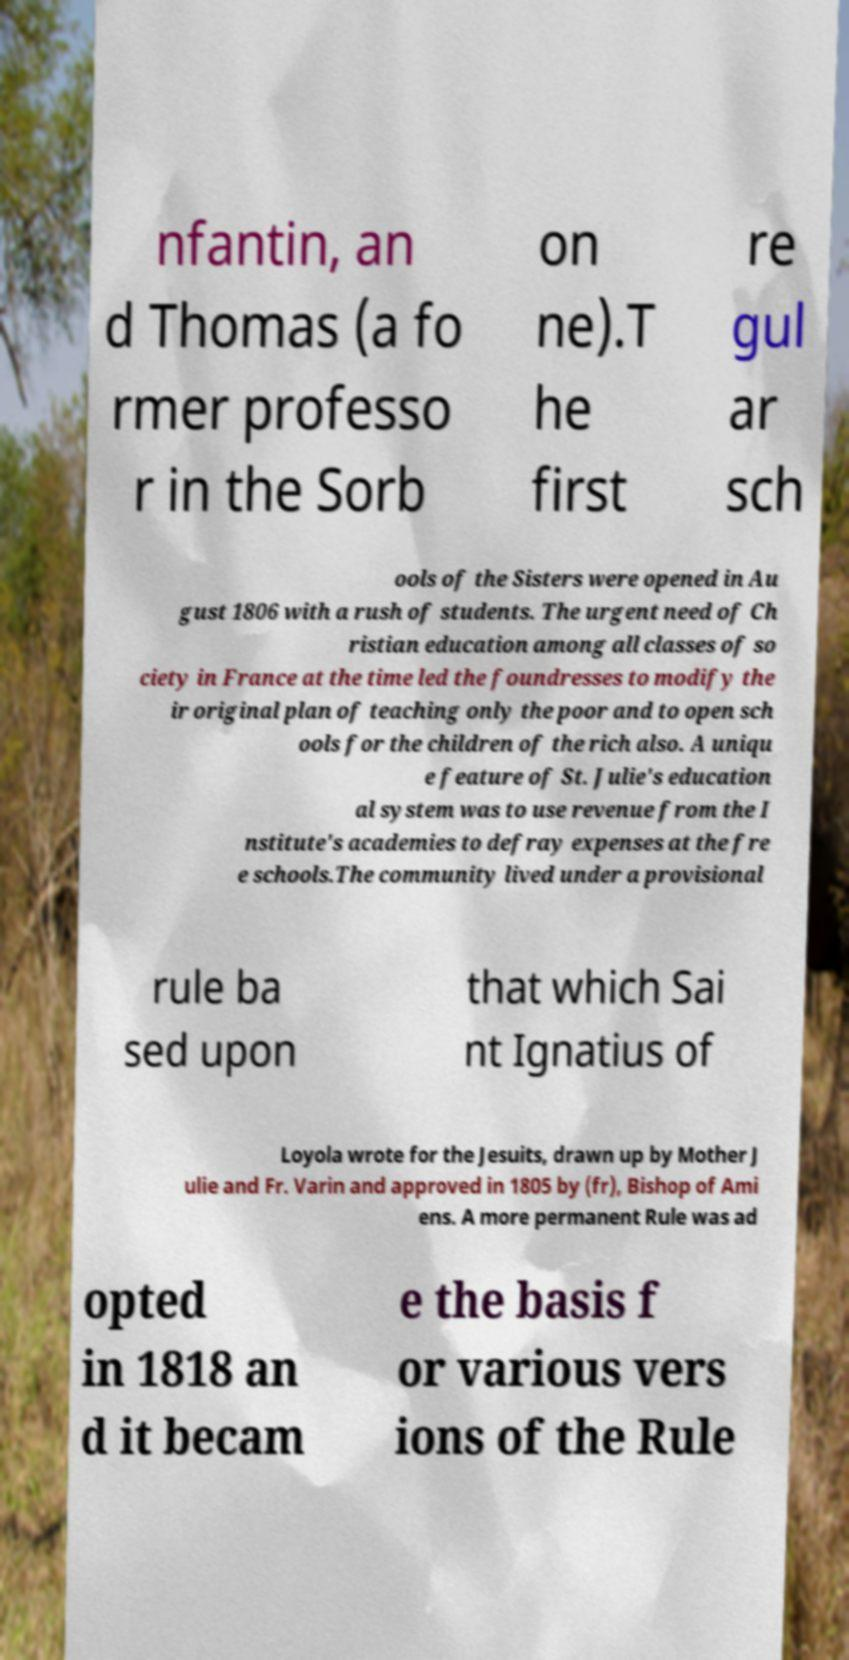Please read and relay the text visible in this image. What does it say? nfantin, an d Thomas (a fo rmer professo r in the Sorb on ne).T he first re gul ar sch ools of the Sisters were opened in Au gust 1806 with a rush of students. The urgent need of Ch ristian education among all classes of so ciety in France at the time led the foundresses to modify the ir original plan of teaching only the poor and to open sch ools for the children of the rich also. A uniqu e feature of St. Julie's education al system was to use revenue from the I nstitute's academies to defray expenses at the fre e schools.The community lived under a provisional rule ba sed upon that which Sai nt Ignatius of Loyola wrote for the Jesuits, drawn up by Mother J ulie and Fr. Varin and approved in 1805 by (fr), Bishop of Ami ens. A more permanent Rule was ad opted in 1818 an d it becam e the basis f or various vers ions of the Rule 